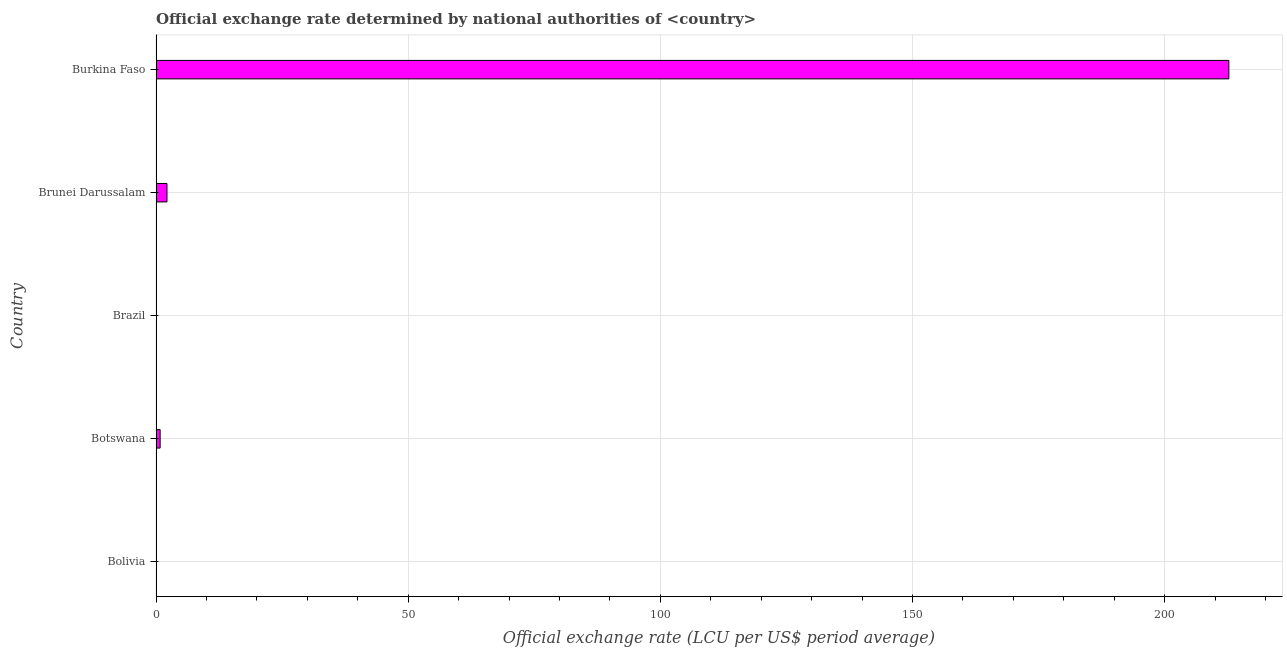What is the title of the graph?
Your answer should be compact. Official exchange rate determined by national authorities of <country>. What is the label or title of the X-axis?
Provide a succinct answer. Official exchange rate (LCU per US$ period average). What is the official exchange rate in Burkina Faso?
Offer a very short reply. 212.72. Across all countries, what is the maximum official exchange rate?
Offer a very short reply. 212.72. Across all countries, what is the minimum official exchange rate?
Keep it short and to the point. 1.1660690720063e-11. In which country was the official exchange rate maximum?
Your response must be concise. Burkina Faso. In which country was the official exchange rate minimum?
Your answer should be very brief. Brazil. What is the sum of the official exchange rate?
Provide a short and direct response. 215.71. What is the difference between the official exchange rate in Bolivia and Brunei Darussalam?
Your response must be concise. -2.17. What is the average official exchange rate per country?
Give a very brief answer. 43.14. What is the median official exchange rate?
Offer a terse response. 0.82. What is the ratio of the official exchange rate in Brunei Darussalam to that in Burkina Faso?
Ensure brevity in your answer.  0.01. Is the official exchange rate in Brazil less than that in Brunei Darussalam?
Provide a succinct answer. Yes. What is the difference between the highest and the second highest official exchange rate?
Provide a short and direct response. 210.55. What is the difference between the highest and the lowest official exchange rate?
Offer a very short reply. 212.72. How many bars are there?
Provide a short and direct response. 5. Are all the bars in the graph horizontal?
Provide a succinct answer. Yes. How many countries are there in the graph?
Keep it short and to the point. 5. What is the difference between two consecutive major ticks on the X-axis?
Offer a very short reply. 50. Are the values on the major ticks of X-axis written in scientific E-notation?
Provide a short and direct response. No. What is the Official exchange rate (LCU per US$ period average) in Bolivia?
Provide a short and direct response. 2.04033333333333e-5. What is the Official exchange rate (LCU per US$ period average) of Botswana?
Offer a very short reply. 0.82. What is the Official exchange rate (LCU per US$ period average) of Brazil?
Offer a terse response. 1.1660690720063e-11. What is the Official exchange rate (LCU per US$ period average) of Brunei Darussalam?
Give a very brief answer. 2.17. What is the Official exchange rate (LCU per US$ period average) in Burkina Faso?
Offer a very short reply. 212.72. What is the difference between the Official exchange rate (LCU per US$ period average) in Bolivia and Botswana?
Ensure brevity in your answer.  -0.81. What is the difference between the Official exchange rate (LCU per US$ period average) in Bolivia and Brazil?
Make the answer very short. 2e-5. What is the difference between the Official exchange rate (LCU per US$ period average) in Bolivia and Brunei Darussalam?
Provide a succinct answer. -2.17. What is the difference between the Official exchange rate (LCU per US$ period average) in Bolivia and Burkina Faso?
Your answer should be very brief. -212.72. What is the difference between the Official exchange rate (LCU per US$ period average) in Botswana and Brazil?
Ensure brevity in your answer.  0.82. What is the difference between the Official exchange rate (LCU per US$ period average) in Botswana and Brunei Darussalam?
Your answer should be very brief. -1.36. What is the difference between the Official exchange rate (LCU per US$ period average) in Botswana and Burkina Faso?
Your answer should be compact. -211.91. What is the difference between the Official exchange rate (LCU per US$ period average) in Brazil and Brunei Darussalam?
Make the answer very short. -2.17. What is the difference between the Official exchange rate (LCU per US$ period average) in Brazil and Burkina Faso?
Provide a short and direct response. -212.72. What is the difference between the Official exchange rate (LCU per US$ period average) in Brunei Darussalam and Burkina Faso?
Keep it short and to the point. -210.55. What is the ratio of the Official exchange rate (LCU per US$ period average) in Bolivia to that in Brazil?
Keep it short and to the point. 1.75e+06. What is the ratio of the Official exchange rate (LCU per US$ period average) in Bolivia to that in Brunei Darussalam?
Make the answer very short. 0. What is the ratio of the Official exchange rate (LCU per US$ period average) in Bolivia to that in Burkina Faso?
Offer a very short reply. 0. What is the ratio of the Official exchange rate (LCU per US$ period average) in Botswana to that in Brazil?
Make the answer very short. 6.99e+1. What is the ratio of the Official exchange rate (LCU per US$ period average) in Botswana to that in Brunei Darussalam?
Offer a terse response. 0.38. What is the ratio of the Official exchange rate (LCU per US$ period average) in Botswana to that in Burkina Faso?
Your answer should be very brief. 0. What is the ratio of the Official exchange rate (LCU per US$ period average) in Brazil to that in Brunei Darussalam?
Keep it short and to the point. 0. What is the ratio of the Official exchange rate (LCU per US$ period average) in Brunei Darussalam to that in Burkina Faso?
Your response must be concise. 0.01. 